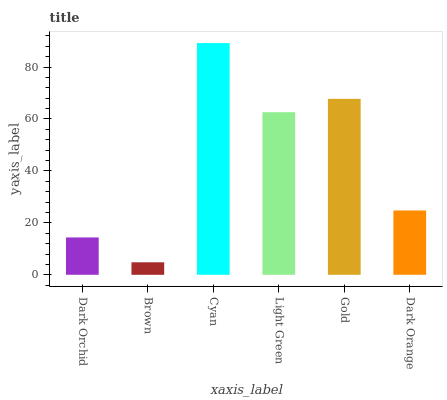Is Brown the minimum?
Answer yes or no. Yes. Is Cyan the maximum?
Answer yes or no. Yes. Is Cyan the minimum?
Answer yes or no. No. Is Brown the maximum?
Answer yes or no. No. Is Cyan greater than Brown?
Answer yes or no. Yes. Is Brown less than Cyan?
Answer yes or no. Yes. Is Brown greater than Cyan?
Answer yes or no. No. Is Cyan less than Brown?
Answer yes or no. No. Is Light Green the high median?
Answer yes or no. Yes. Is Dark Orange the low median?
Answer yes or no. Yes. Is Cyan the high median?
Answer yes or no. No. Is Brown the low median?
Answer yes or no. No. 